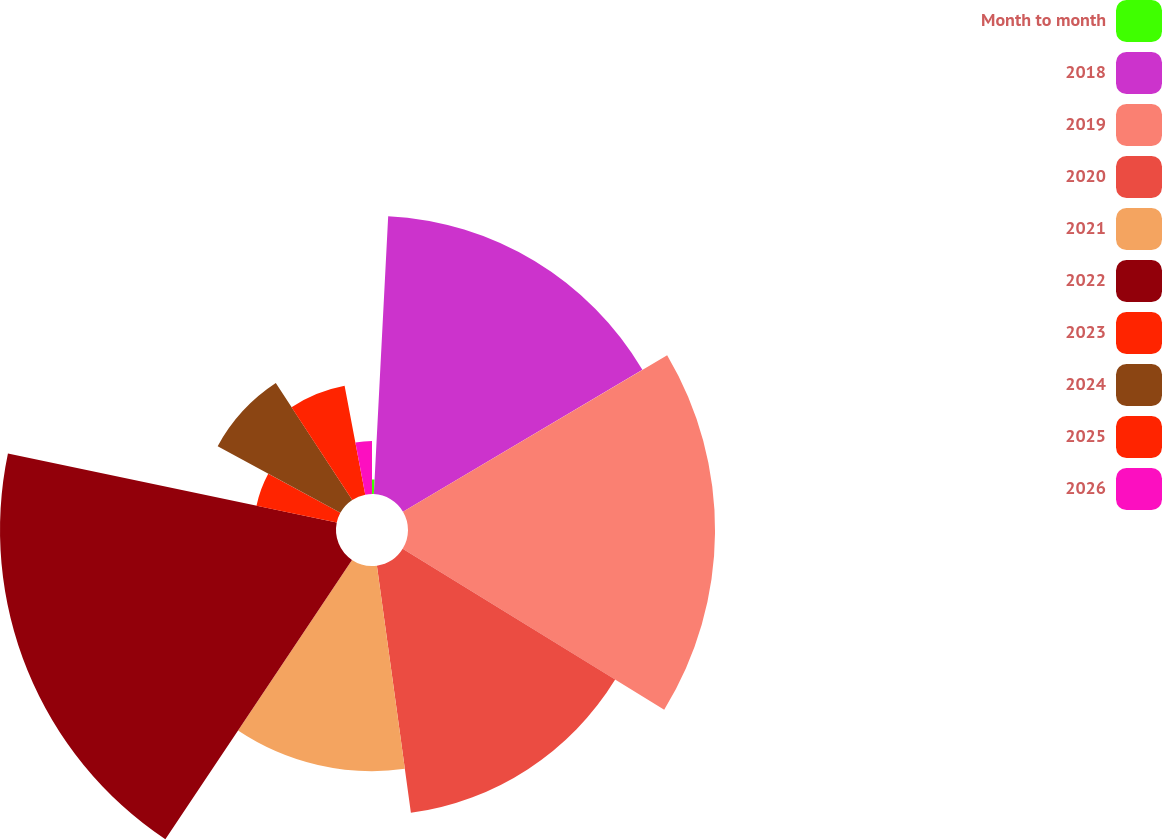Convert chart to OTSL. <chart><loc_0><loc_0><loc_500><loc_500><pie_chart><fcel>Month to month<fcel>2018<fcel>2019<fcel>2020<fcel>2021<fcel>2022<fcel>2023<fcel>2024<fcel>2025<fcel>2026<nl><fcel>0.82%<fcel>15.67%<fcel>17.29%<fcel>14.05%<fcel>11.55%<fcel>18.92%<fcel>4.62%<fcel>7.86%<fcel>6.24%<fcel>2.99%<nl></chart> 